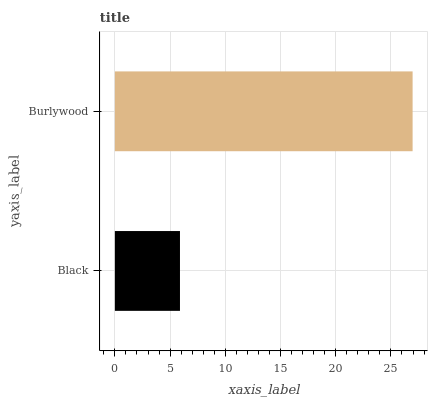Is Black the minimum?
Answer yes or no. Yes. Is Burlywood the maximum?
Answer yes or no. Yes. Is Burlywood the minimum?
Answer yes or no. No. Is Burlywood greater than Black?
Answer yes or no. Yes. Is Black less than Burlywood?
Answer yes or no. Yes. Is Black greater than Burlywood?
Answer yes or no. No. Is Burlywood less than Black?
Answer yes or no. No. Is Burlywood the high median?
Answer yes or no. Yes. Is Black the low median?
Answer yes or no. Yes. Is Black the high median?
Answer yes or no. No. Is Burlywood the low median?
Answer yes or no. No. 